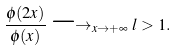Convert formula to latex. <formula><loc_0><loc_0><loc_500><loc_500>\frac { \phi ( 2 x ) } { \phi ( x ) } \longrightarrow _ { x \to + \infty } l > 1 .</formula> 